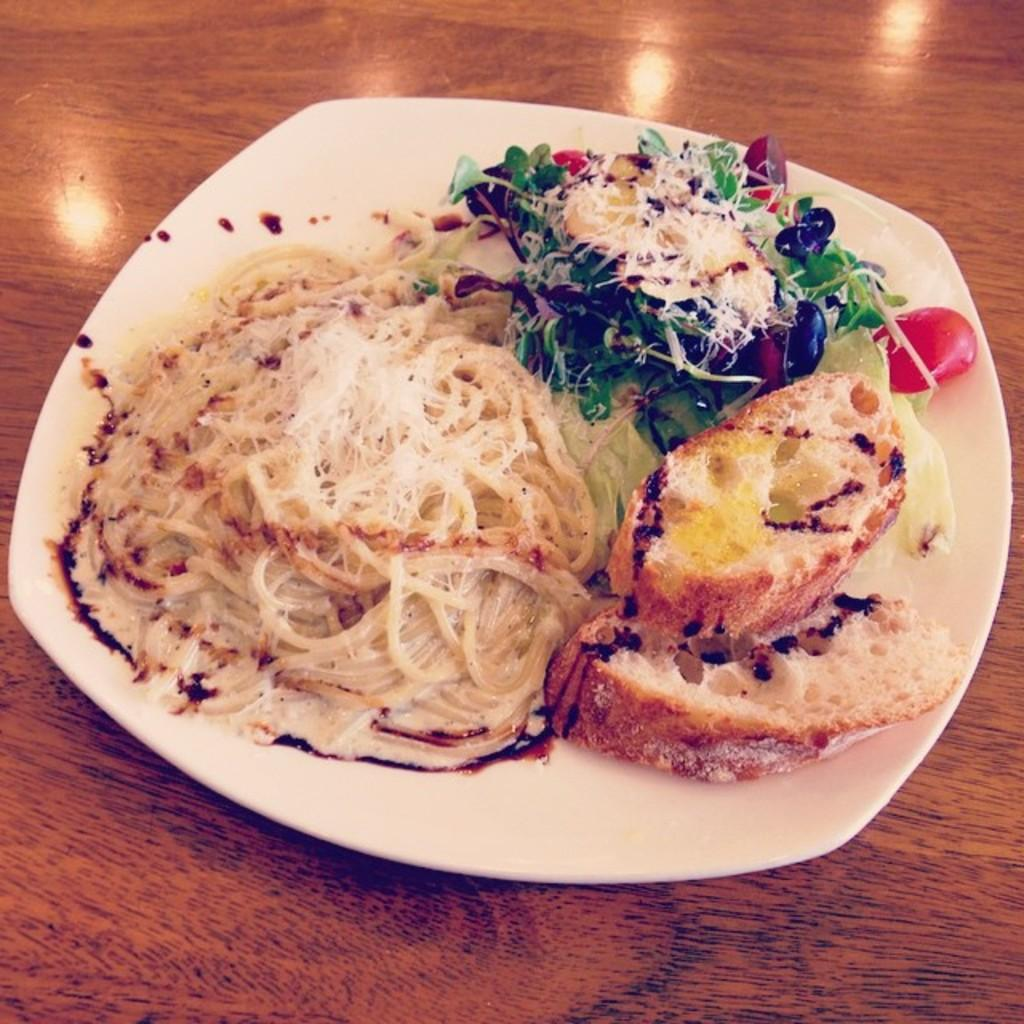What type of food is served on the plate in the image? There is food served on a plate in the image, including two bread slices, spaghetti, and salad. How many bread slices are on the plate? There are two bread slices on the plate. What other types of food are on the plate? There is spaghetti and salad on the plate. Where is the plate placed in the image? The plate is placed on a table. How much money is visible on the plate in the image? There is no money visible on the plate in the image; it contains food items such as bread, spaghetti, and salad. What type of net is used to catch the fish on the plate? There are no fish or nets present in the image; it features a plate of food with bread, spaghetti, and salad. 